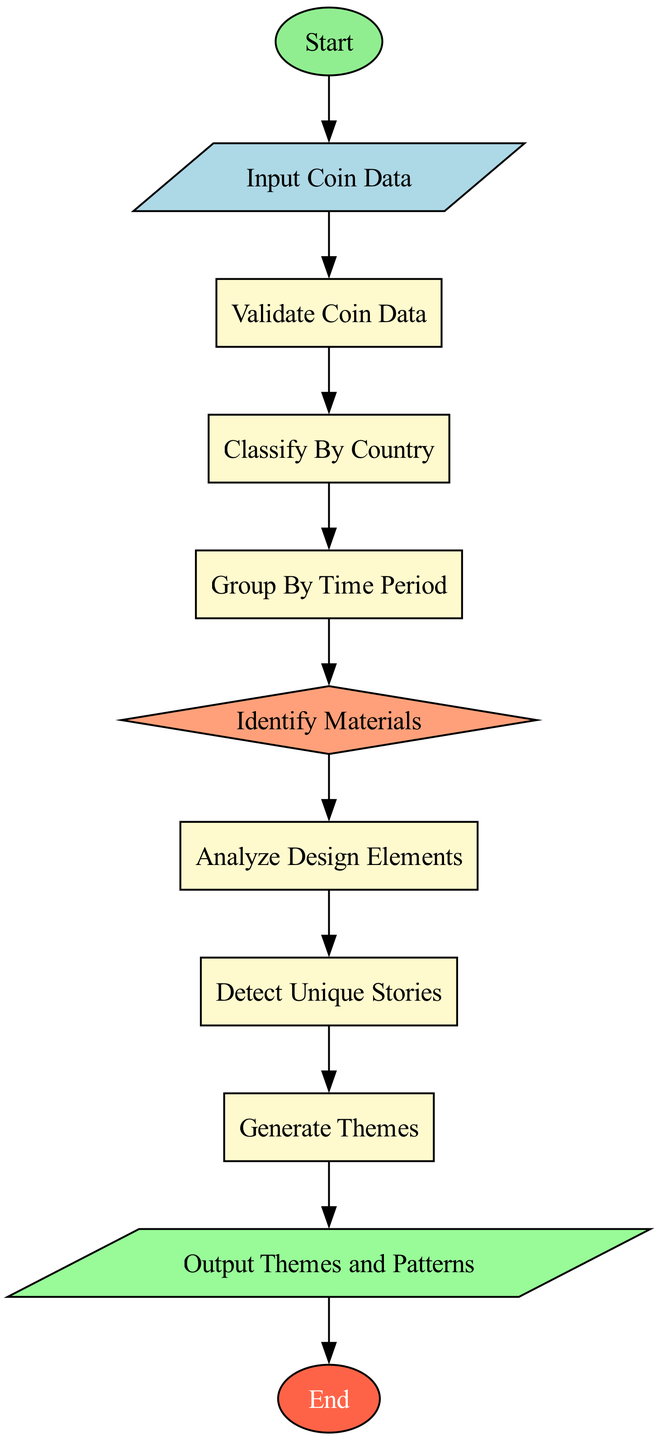What is the first step in the process? The first node in the diagram is labeled "Start," indicating the initiation of the coin theme identification process.
Answer: Start How many total nodes are in the diagram? By counting each unique element in the diagram, there are 11 nodes present in total.
Answer: 11 What step comes after "Input Coin Data"? The next step following "Input Coin Data" is "Validate Coin Data," which checks the completeness and validity of the provided data.
Answer: Validate Coin Data Which node represents the decision-making process? The "Identify Materials" node is structured as a diamond shape, which indicates a decision point where coins are categorized based on their material.
Answer: Identify Materials How many output steps are there in the diagram? There is one output step, which is the node labeled "Output Themes and Patterns," summarizing the themes identified during the process.
Answer: 1 What is the final step in the process? The last node labeled "End" denotes the termination point of the coin theme identification process, concluding all preceding activities.
Answer: End If the coin data is invalid, what process is skipped? If the coin data is invalid, the subsequent step "Classify By Country" is skipped and not processed.
Answer: Classify By Country What is the relationship between "Group By Time Period" and "Generate Themes"? "Group By Time Period" must occur before "Generate Themes" as the grouping of coins informs the generation of themes based on identified patterns.
Answer: Sequential In which order do the processes occur after the decision node? After the "Identify Materials" decision node, the processes proceed through "Analyze Design Elements," "Detect Unique Stories," and finally to "Generate Themes," following a linear path from one to the next.
Answer: Linear 